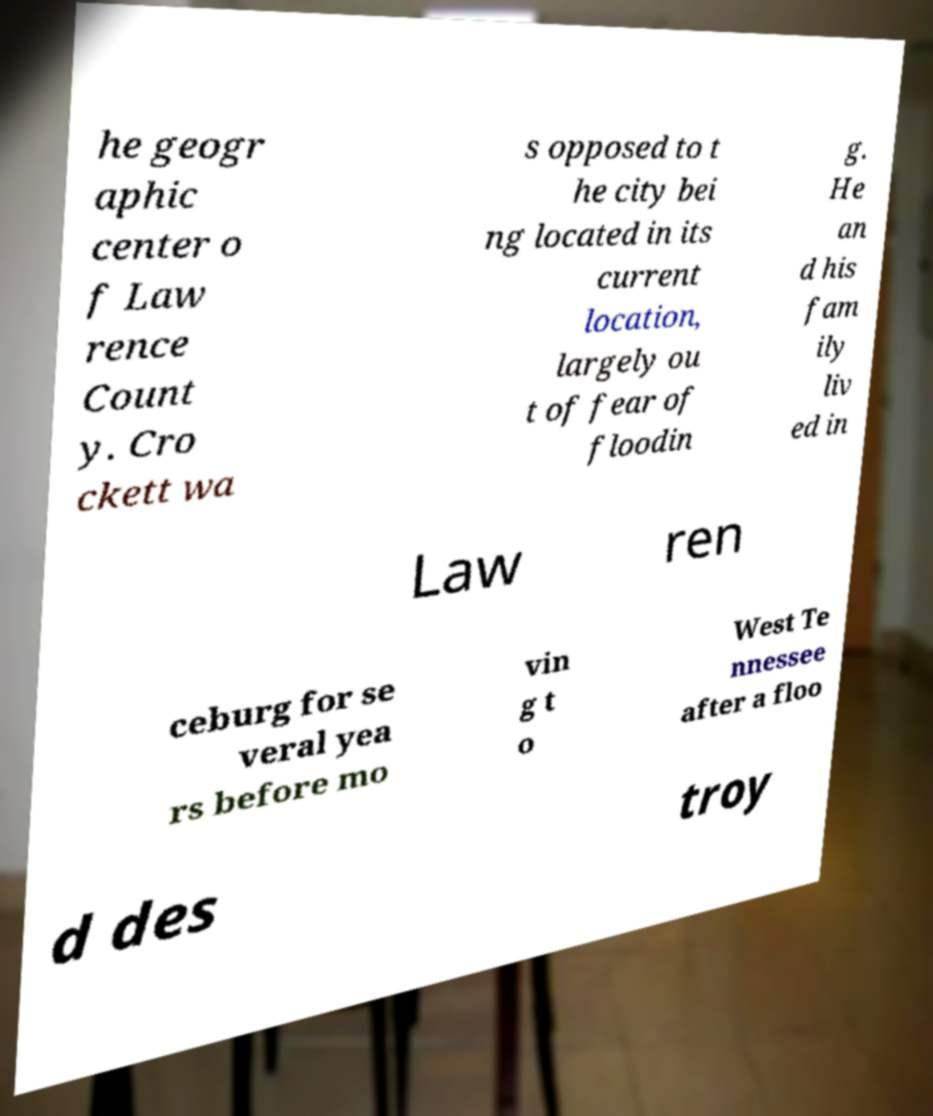Can you read and provide the text displayed in the image?This photo seems to have some interesting text. Can you extract and type it out for me? he geogr aphic center o f Law rence Count y. Cro ckett wa s opposed to t he city bei ng located in its current location, largely ou t of fear of floodin g. He an d his fam ily liv ed in Law ren ceburg for se veral yea rs before mo vin g t o West Te nnessee after a floo d des troy 